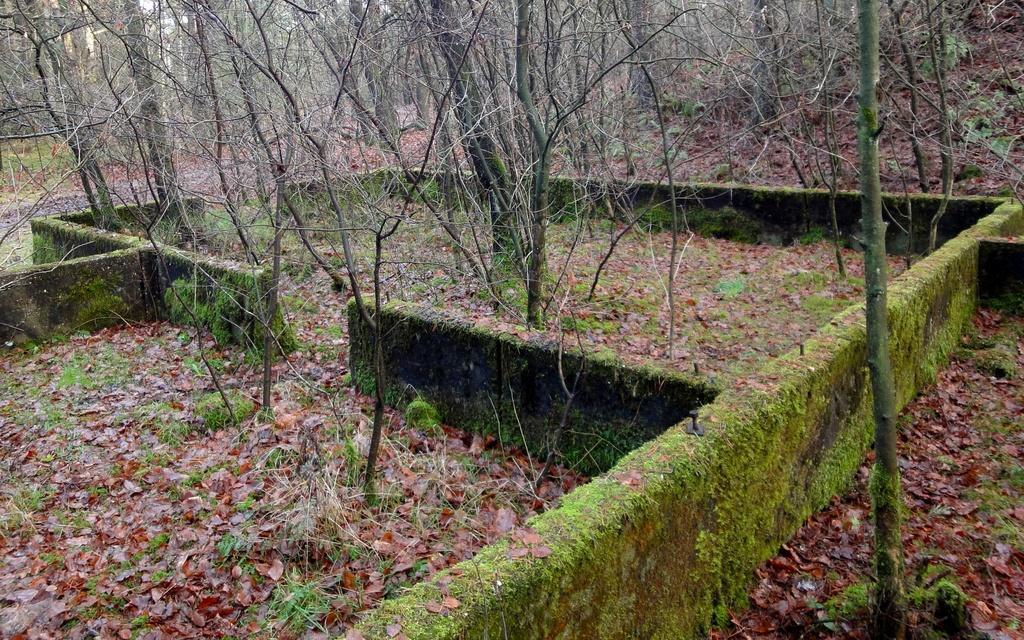What type of structure can be seen in the image? There are walls in the image. What natural elements are present in the image? Dried leaves and trees are present in the image. Where are the trees located in relation to the walls? The trees are on the ground in the image. How many cacti can be seen in the image? There are no cacti present in the image. What is the distance between the walls in the image? The provided facts do not give information about the distance between the walls, so it cannot be determined from the image. 